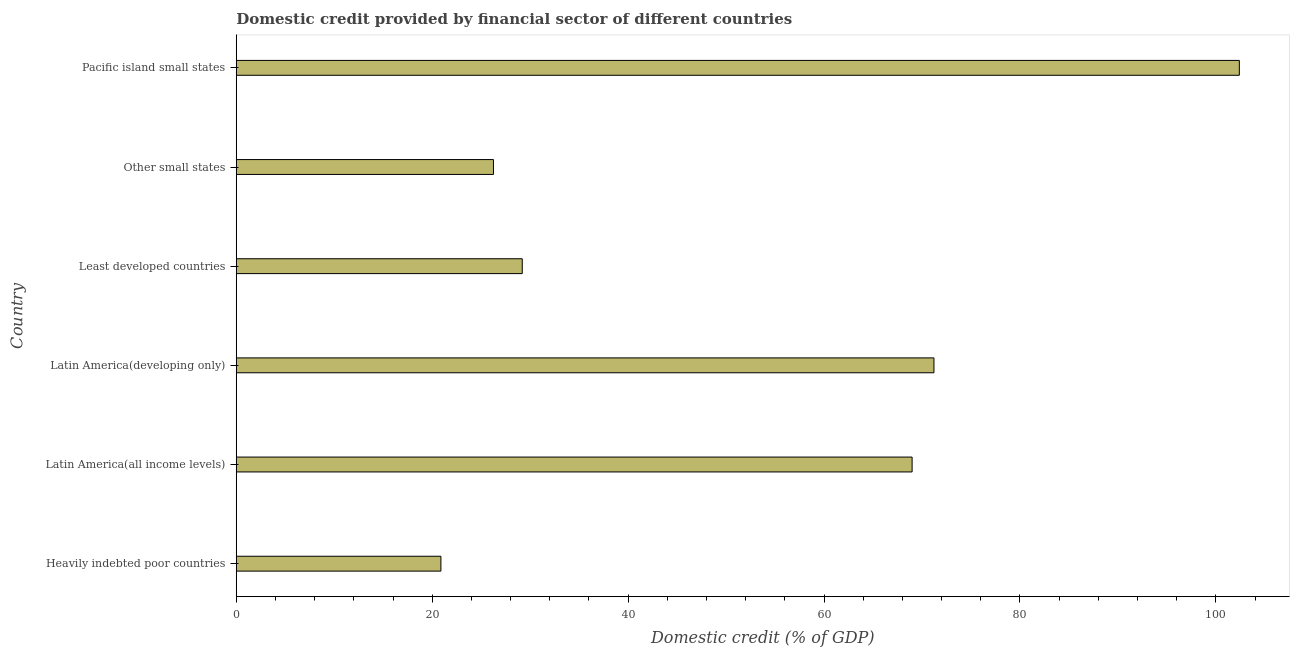Does the graph contain any zero values?
Your response must be concise. No. Does the graph contain grids?
Make the answer very short. No. What is the title of the graph?
Your answer should be very brief. Domestic credit provided by financial sector of different countries. What is the label or title of the X-axis?
Keep it short and to the point. Domestic credit (% of GDP). What is the label or title of the Y-axis?
Give a very brief answer. Country. What is the domestic credit provided by financial sector in Latin America(developing only)?
Your response must be concise. 71.22. Across all countries, what is the maximum domestic credit provided by financial sector?
Provide a succinct answer. 102.39. Across all countries, what is the minimum domestic credit provided by financial sector?
Offer a terse response. 20.89. In which country was the domestic credit provided by financial sector maximum?
Your answer should be very brief. Pacific island small states. In which country was the domestic credit provided by financial sector minimum?
Your answer should be very brief. Heavily indebted poor countries. What is the sum of the domestic credit provided by financial sector?
Make the answer very short. 318.94. What is the difference between the domestic credit provided by financial sector in Heavily indebted poor countries and Latin America(developing only)?
Offer a very short reply. -50.33. What is the average domestic credit provided by financial sector per country?
Provide a short and direct response. 53.16. What is the median domestic credit provided by financial sector?
Keep it short and to the point. 49.09. In how many countries, is the domestic credit provided by financial sector greater than 16 %?
Your answer should be very brief. 6. What is the ratio of the domestic credit provided by financial sector in Latin America(developing only) to that in Least developed countries?
Provide a short and direct response. 2.44. Is the domestic credit provided by financial sector in Latin America(developing only) less than that in Least developed countries?
Offer a terse response. No. What is the difference between the highest and the second highest domestic credit provided by financial sector?
Your answer should be compact. 31.17. Is the sum of the domestic credit provided by financial sector in Least developed countries and Other small states greater than the maximum domestic credit provided by financial sector across all countries?
Provide a short and direct response. No. What is the difference between the highest and the lowest domestic credit provided by financial sector?
Your answer should be compact. 81.5. Are all the bars in the graph horizontal?
Make the answer very short. Yes. Are the values on the major ticks of X-axis written in scientific E-notation?
Your response must be concise. No. What is the Domestic credit (% of GDP) of Heavily indebted poor countries?
Keep it short and to the point. 20.89. What is the Domestic credit (% of GDP) in Latin America(all income levels)?
Your answer should be compact. 68.99. What is the Domestic credit (% of GDP) in Latin America(developing only)?
Keep it short and to the point. 71.22. What is the Domestic credit (% of GDP) of Least developed countries?
Provide a short and direct response. 29.19. What is the Domestic credit (% of GDP) in Other small states?
Your answer should be very brief. 26.25. What is the Domestic credit (% of GDP) in Pacific island small states?
Keep it short and to the point. 102.39. What is the difference between the Domestic credit (% of GDP) in Heavily indebted poor countries and Latin America(all income levels)?
Give a very brief answer. -48.1. What is the difference between the Domestic credit (% of GDP) in Heavily indebted poor countries and Latin America(developing only)?
Provide a short and direct response. -50.33. What is the difference between the Domestic credit (% of GDP) in Heavily indebted poor countries and Least developed countries?
Your answer should be compact. -8.3. What is the difference between the Domestic credit (% of GDP) in Heavily indebted poor countries and Other small states?
Keep it short and to the point. -5.36. What is the difference between the Domestic credit (% of GDP) in Heavily indebted poor countries and Pacific island small states?
Your response must be concise. -81.5. What is the difference between the Domestic credit (% of GDP) in Latin America(all income levels) and Latin America(developing only)?
Make the answer very short. -2.23. What is the difference between the Domestic credit (% of GDP) in Latin America(all income levels) and Least developed countries?
Offer a terse response. 39.79. What is the difference between the Domestic credit (% of GDP) in Latin America(all income levels) and Other small states?
Offer a terse response. 42.73. What is the difference between the Domestic credit (% of GDP) in Latin America(all income levels) and Pacific island small states?
Offer a terse response. -33.4. What is the difference between the Domestic credit (% of GDP) in Latin America(developing only) and Least developed countries?
Keep it short and to the point. 42.02. What is the difference between the Domestic credit (% of GDP) in Latin America(developing only) and Other small states?
Offer a very short reply. 44.96. What is the difference between the Domestic credit (% of GDP) in Latin America(developing only) and Pacific island small states?
Provide a short and direct response. -31.17. What is the difference between the Domestic credit (% of GDP) in Least developed countries and Other small states?
Your response must be concise. 2.94. What is the difference between the Domestic credit (% of GDP) in Least developed countries and Pacific island small states?
Provide a short and direct response. -73.2. What is the difference between the Domestic credit (% of GDP) in Other small states and Pacific island small states?
Ensure brevity in your answer.  -76.14. What is the ratio of the Domestic credit (% of GDP) in Heavily indebted poor countries to that in Latin America(all income levels)?
Ensure brevity in your answer.  0.3. What is the ratio of the Domestic credit (% of GDP) in Heavily indebted poor countries to that in Latin America(developing only)?
Provide a short and direct response. 0.29. What is the ratio of the Domestic credit (% of GDP) in Heavily indebted poor countries to that in Least developed countries?
Ensure brevity in your answer.  0.72. What is the ratio of the Domestic credit (% of GDP) in Heavily indebted poor countries to that in Other small states?
Make the answer very short. 0.8. What is the ratio of the Domestic credit (% of GDP) in Heavily indebted poor countries to that in Pacific island small states?
Your answer should be compact. 0.2. What is the ratio of the Domestic credit (% of GDP) in Latin America(all income levels) to that in Latin America(developing only)?
Offer a very short reply. 0.97. What is the ratio of the Domestic credit (% of GDP) in Latin America(all income levels) to that in Least developed countries?
Keep it short and to the point. 2.36. What is the ratio of the Domestic credit (% of GDP) in Latin America(all income levels) to that in Other small states?
Give a very brief answer. 2.63. What is the ratio of the Domestic credit (% of GDP) in Latin America(all income levels) to that in Pacific island small states?
Give a very brief answer. 0.67. What is the ratio of the Domestic credit (% of GDP) in Latin America(developing only) to that in Least developed countries?
Keep it short and to the point. 2.44. What is the ratio of the Domestic credit (% of GDP) in Latin America(developing only) to that in Other small states?
Offer a very short reply. 2.71. What is the ratio of the Domestic credit (% of GDP) in Latin America(developing only) to that in Pacific island small states?
Offer a terse response. 0.7. What is the ratio of the Domestic credit (% of GDP) in Least developed countries to that in Other small states?
Your response must be concise. 1.11. What is the ratio of the Domestic credit (% of GDP) in Least developed countries to that in Pacific island small states?
Give a very brief answer. 0.28. What is the ratio of the Domestic credit (% of GDP) in Other small states to that in Pacific island small states?
Give a very brief answer. 0.26. 